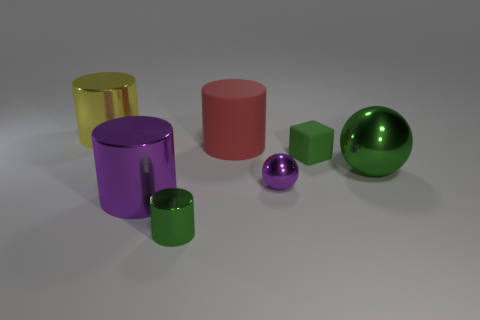Add 3 green rubber things. How many objects exist? 10 Subtract all spheres. How many objects are left? 5 Subtract 1 red cylinders. How many objects are left? 6 Subtract all large shiny balls. Subtract all large purple cylinders. How many objects are left? 5 Add 2 rubber objects. How many rubber objects are left? 4 Add 6 green metal balls. How many green metal balls exist? 7 